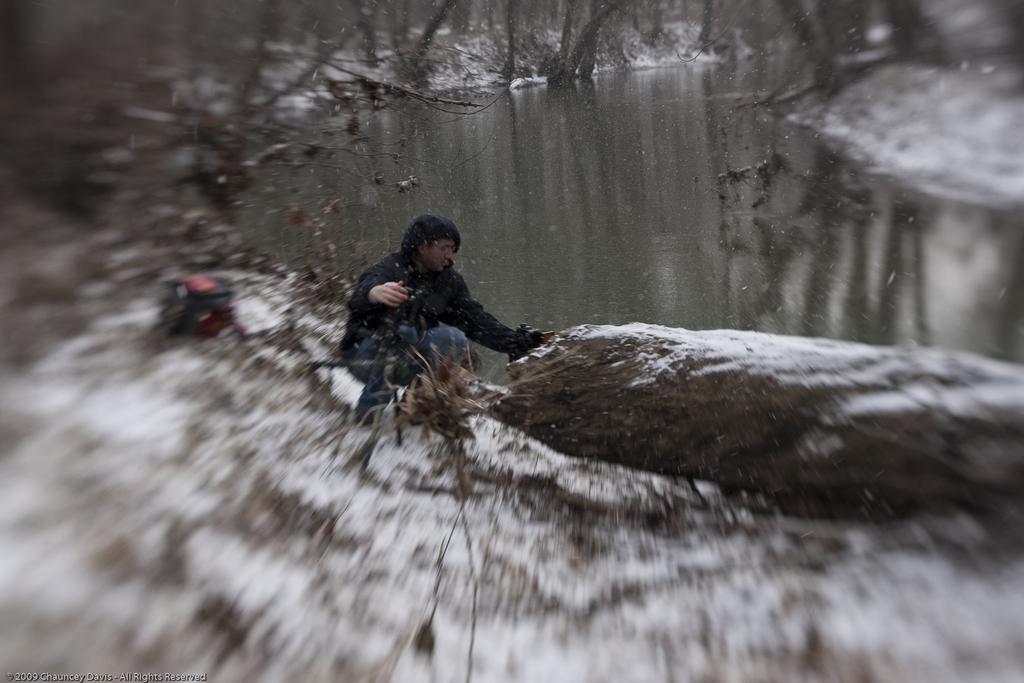What is the person in the image wearing? The person in the image is wearing a black color jacket. What is the ground made of in the image? There is snow at the bottom of the image. What can be seen in the distance in the image? There is water visible in the background of the image. What type of vegetation is present in the background of the image? There are trees in the background of the image. What type of skirt is the person wearing in the image? The person in the image is not wearing a skirt; they are wearing a black color jacket. 